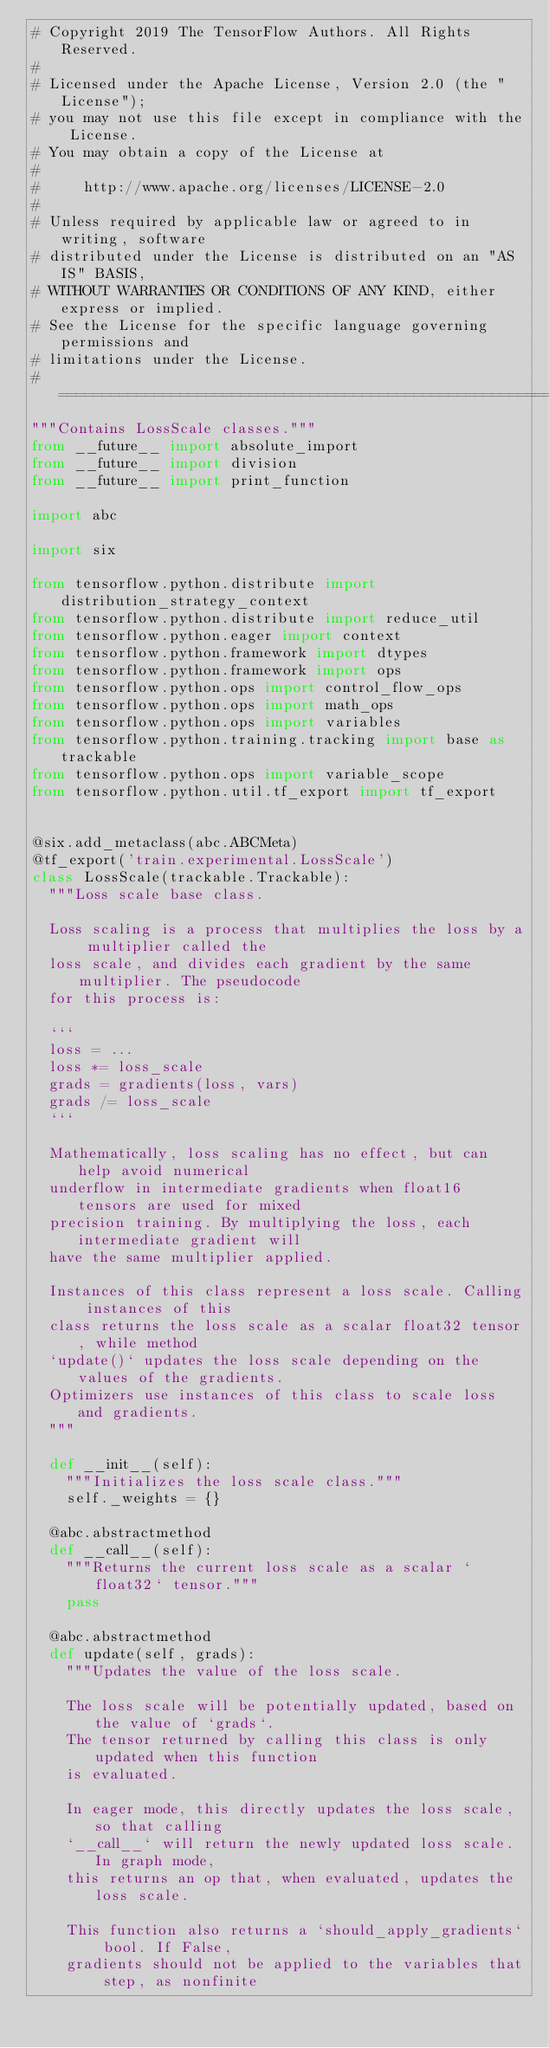Convert code to text. <code><loc_0><loc_0><loc_500><loc_500><_Python_># Copyright 2019 The TensorFlow Authors. All Rights Reserved.
#
# Licensed under the Apache License, Version 2.0 (the "License");
# you may not use this file except in compliance with the License.
# You may obtain a copy of the License at
#
#     http://www.apache.org/licenses/LICENSE-2.0
#
# Unless required by applicable law or agreed to in writing, software
# distributed under the License is distributed on an "AS IS" BASIS,
# WITHOUT WARRANTIES OR CONDITIONS OF ANY KIND, either express or implied.
# See the License for the specific language governing permissions and
# limitations under the License.
# ==============================================================================
"""Contains LossScale classes."""
from __future__ import absolute_import
from __future__ import division
from __future__ import print_function

import abc

import six

from tensorflow.python.distribute import distribution_strategy_context
from tensorflow.python.distribute import reduce_util
from tensorflow.python.eager import context
from tensorflow.python.framework import dtypes
from tensorflow.python.framework import ops
from tensorflow.python.ops import control_flow_ops
from tensorflow.python.ops import math_ops
from tensorflow.python.ops import variables
from tensorflow.python.training.tracking import base as trackable
from tensorflow.python.ops import variable_scope
from tensorflow.python.util.tf_export import tf_export


@six.add_metaclass(abc.ABCMeta)
@tf_export('train.experimental.LossScale')
class LossScale(trackable.Trackable):
  """Loss scale base class.

  Loss scaling is a process that multiplies the loss by a multiplier called the
  loss scale, and divides each gradient by the same multiplier. The pseudocode
  for this process is:

  ```
  loss = ...
  loss *= loss_scale
  grads = gradients(loss, vars)
  grads /= loss_scale
  ```

  Mathematically, loss scaling has no effect, but can help avoid numerical
  underflow in intermediate gradients when float16 tensors are used for mixed
  precision training. By multiplying the loss, each intermediate gradient will
  have the same multiplier applied.

  Instances of this class represent a loss scale. Calling instances of this
  class returns the loss scale as a scalar float32 tensor, while method
  `update()` updates the loss scale depending on the values of the gradients.
  Optimizers use instances of this class to scale loss and gradients.
  """

  def __init__(self):
    """Initializes the loss scale class."""
    self._weights = {}

  @abc.abstractmethod
  def __call__(self):
    """Returns the current loss scale as a scalar `float32` tensor."""
    pass

  @abc.abstractmethod
  def update(self, grads):
    """Updates the value of the loss scale.

    The loss scale will be potentially updated, based on the value of `grads`.
    The tensor returned by calling this class is only updated when this function
    is evaluated.

    In eager mode, this directly updates the loss scale, so that calling
    `__call__` will return the newly updated loss scale. In graph mode,
    this returns an op that, when evaluated, updates the loss scale.

    This function also returns a `should_apply_gradients` bool. If False,
    gradients should not be applied to the variables that step, as nonfinite</code> 